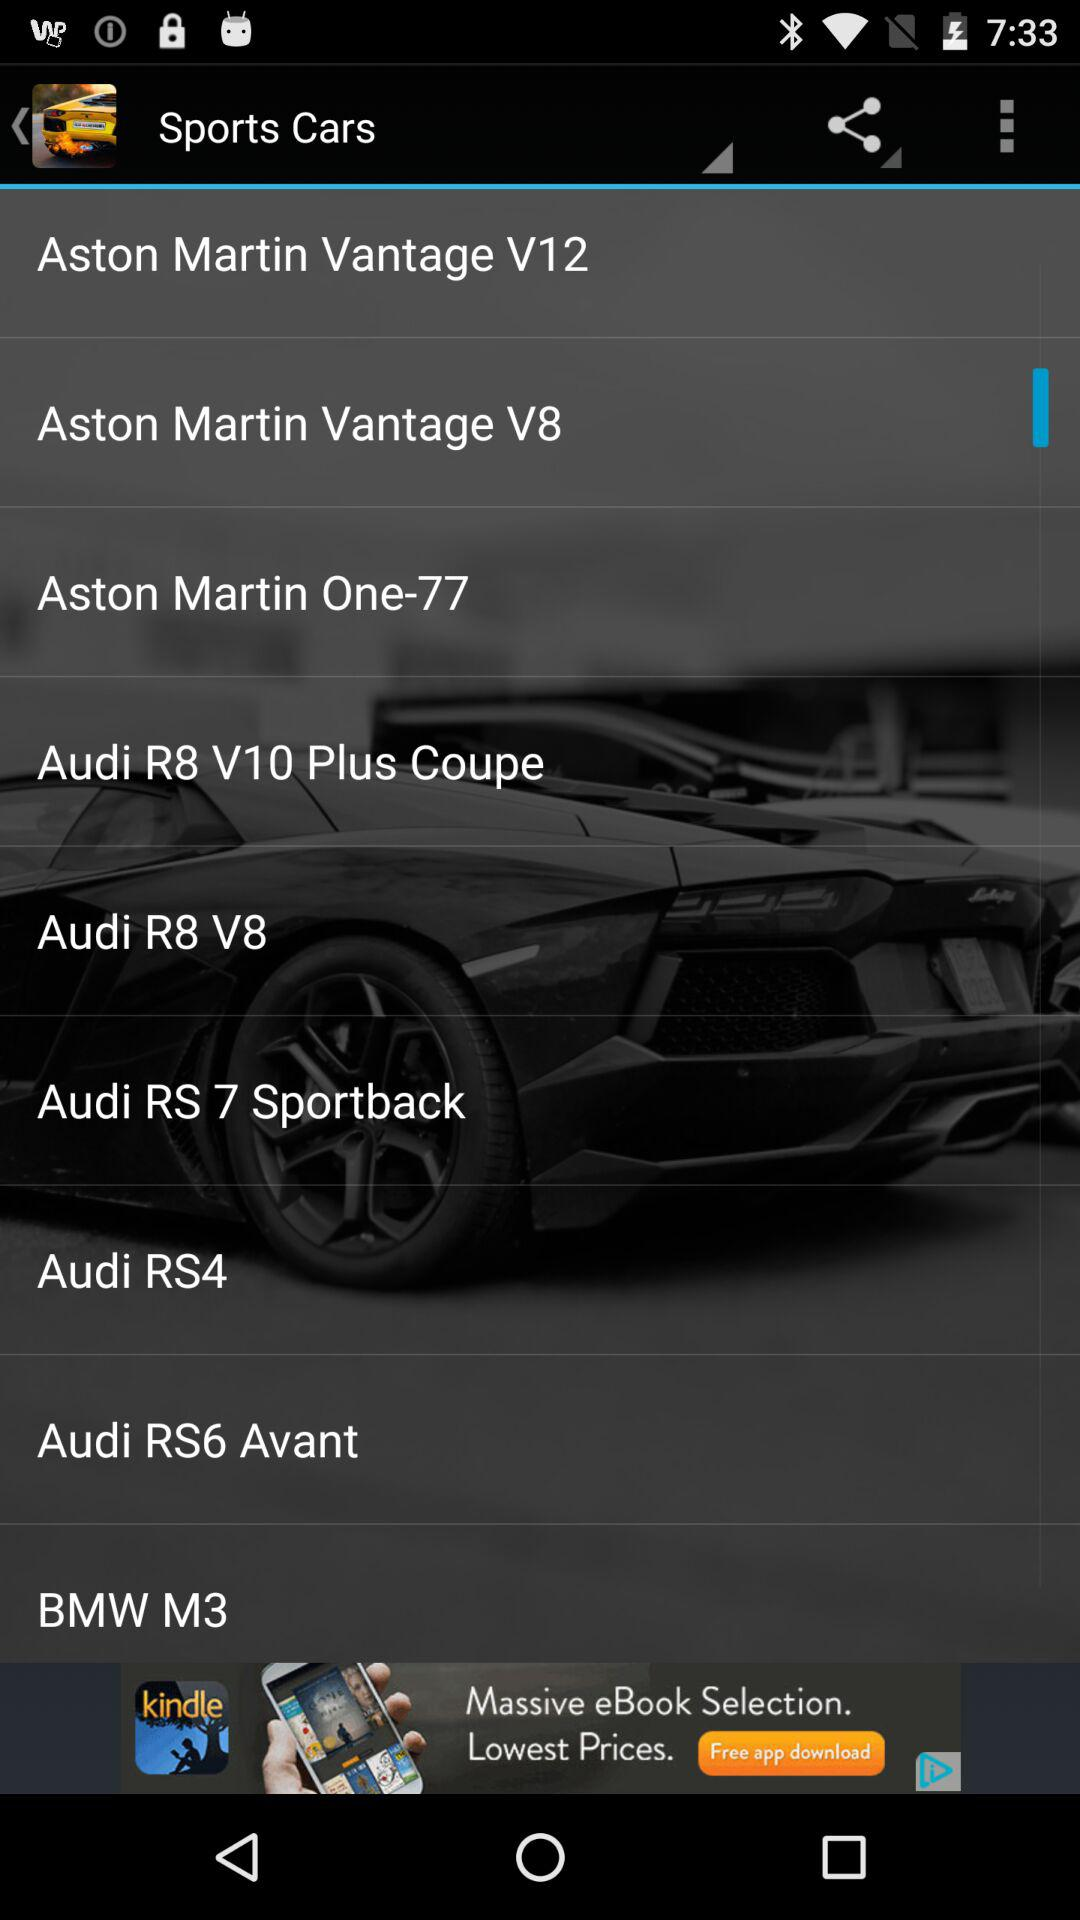What is the model of BMW's car? The model is the "BMW M3". 